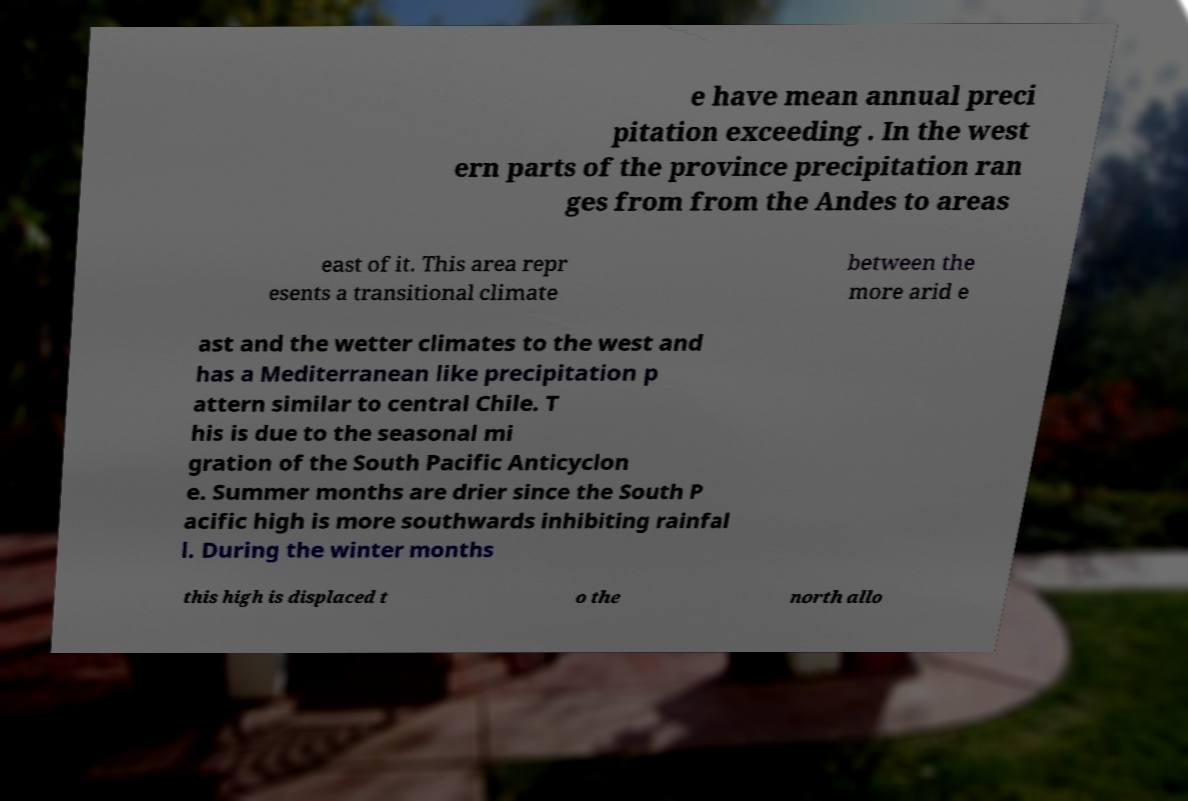What messages or text are displayed in this image? I need them in a readable, typed format. e have mean annual preci pitation exceeding . In the west ern parts of the province precipitation ran ges from from the Andes to areas east of it. This area repr esents a transitional climate between the more arid e ast and the wetter climates to the west and has a Mediterranean like precipitation p attern similar to central Chile. T his is due to the seasonal mi gration of the South Pacific Anticyclon e. Summer months are drier since the South P acific high is more southwards inhibiting rainfal l. During the winter months this high is displaced t o the north allo 